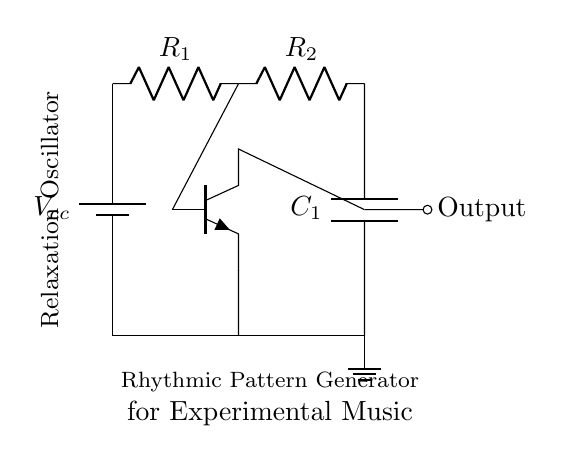What type of oscillator is represented in this circuit? The circuit is identified as a relaxation oscillator based on the configuration of the components, including the use of a capacitor, resistors, and a transistor. These elements characterize the relaxation oscillator's function in generating oscillations.
Answer: Relaxation oscillator What components are used in this circuit? The circuit includes a battery, two resistors (R1 and R2), a capacitor (C1), and an NPN transistor, which are all essential for its operation as a relaxation oscillator.
Answer: Battery, resistors, capacitor, transistor What is the output of the circuit? The output is taken from the collector of the transistor, which generates the rhythmic patterns for experimental music as indicated in the circuit diagram.
Answer: Output How many resistors are present in the circuit? There are two resistors labeled as R1 and R2 in the circuit, which are necessary for determining the charge and discharge time constants of the capacitor.
Answer: Two What role does the capacitor play in the oscillator? The capacitor serves to store and release energy, creating the timing characteristics of the oscillation. It charges through the resistors and eventually triggers the transistor, resulting in oscillation.
Answer: Energy storage How does the transistor affect the circuit's operation? The transistor acts as a switch in this circuit, amplifying the current and enabling the cycle of charging and discharging the capacitor to produce oscillations, which is critical for generating rhythmic patterns in the output.
Answer: Acts as a switch What is the function of the resistor R2? Resistor R2 influences the timing of the charging and discharging of the capacitor, playing a significant role in determining the frequency of the generated oscillations in the circuit.
Answer: Timing control 